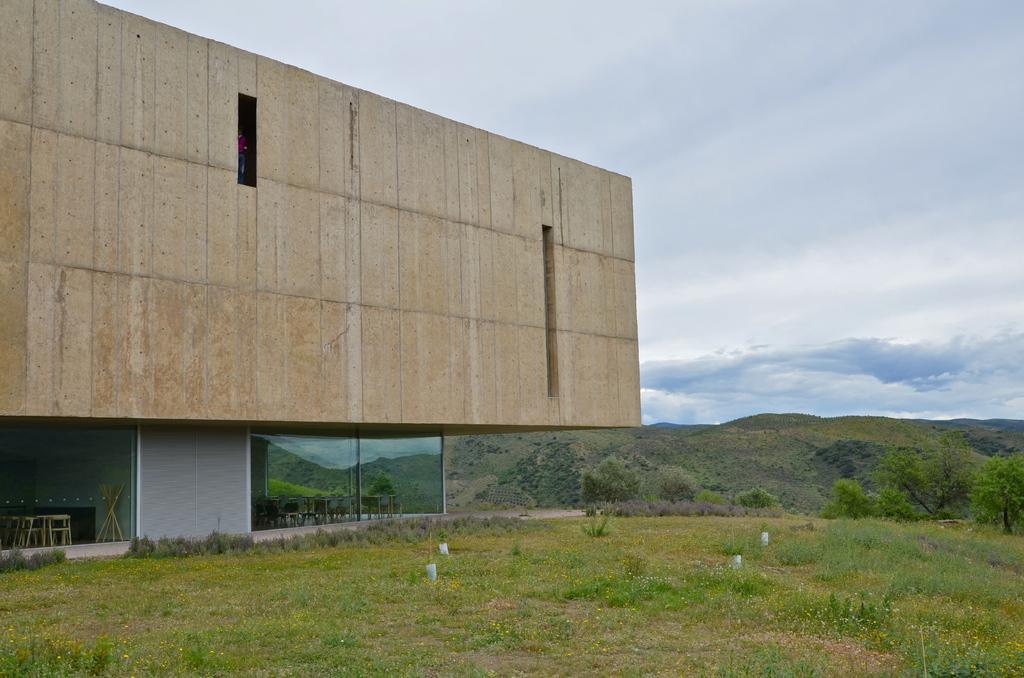How would you summarize this image in a sentence or two? In this image we can see can see a building, cloudy sky, grass and trees. Through this glass windows we can see tables and chairs. 